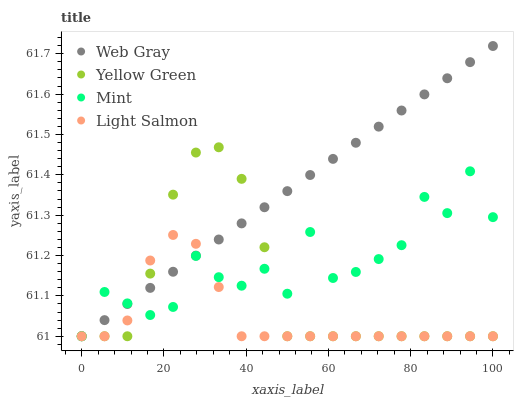Does Light Salmon have the minimum area under the curve?
Answer yes or no. Yes. Does Web Gray have the maximum area under the curve?
Answer yes or no. Yes. Does Mint have the minimum area under the curve?
Answer yes or no. No. Does Mint have the maximum area under the curve?
Answer yes or no. No. Is Web Gray the smoothest?
Answer yes or no. Yes. Is Mint the roughest?
Answer yes or no. Yes. Is Mint the smoothest?
Answer yes or no. No. Is Web Gray the roughest?
Answer yes or no. No. Does Light Salmon have the lowest value?
Answer yes or no. Yes. Does Web Gray have the highest value?
Answer yes or no. Yes. Does Mint have the highest value?
Answer yes or no. No. Does Mint intersect Web Gray?
Answer yes or no. Yes. Is Mint less than Web Gray?
Answer yes or no. No. Is Mint greater than Web Gray?
Answer yes or no. No. 